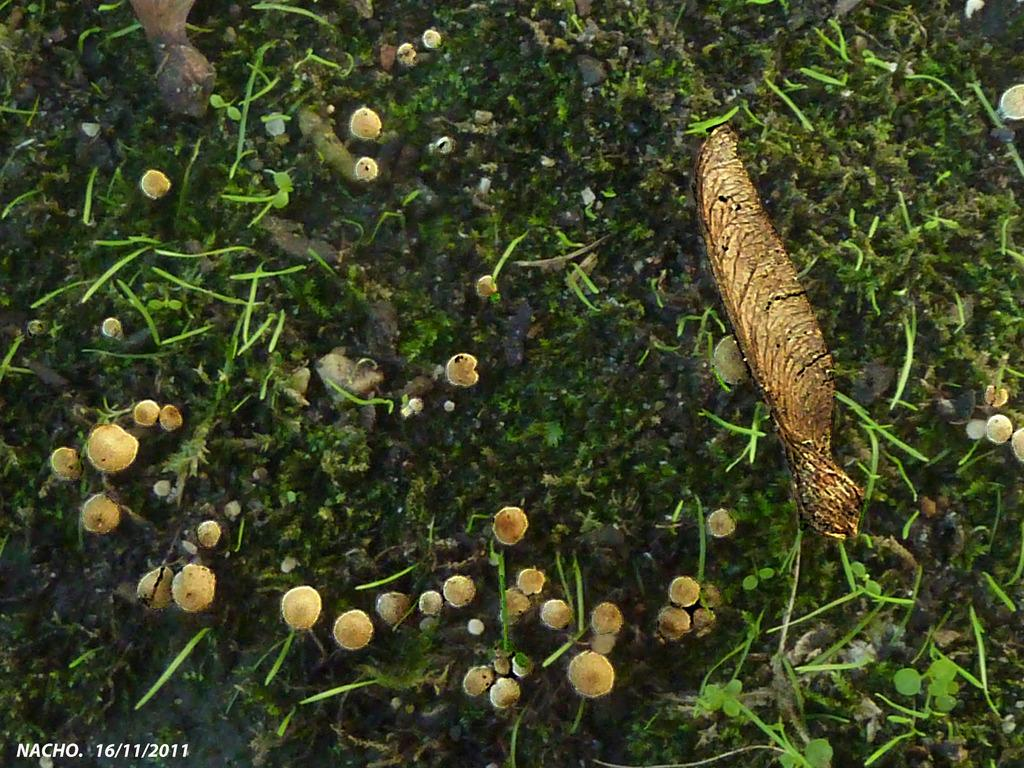What type of plants are in the image? The image contains acacia greggii plants. What size mark can be seen on the acacia greggii plants in the image? There is no mention of any marks on the acacia greggii plants in the image, so it cannot be determined from the provided facts. 